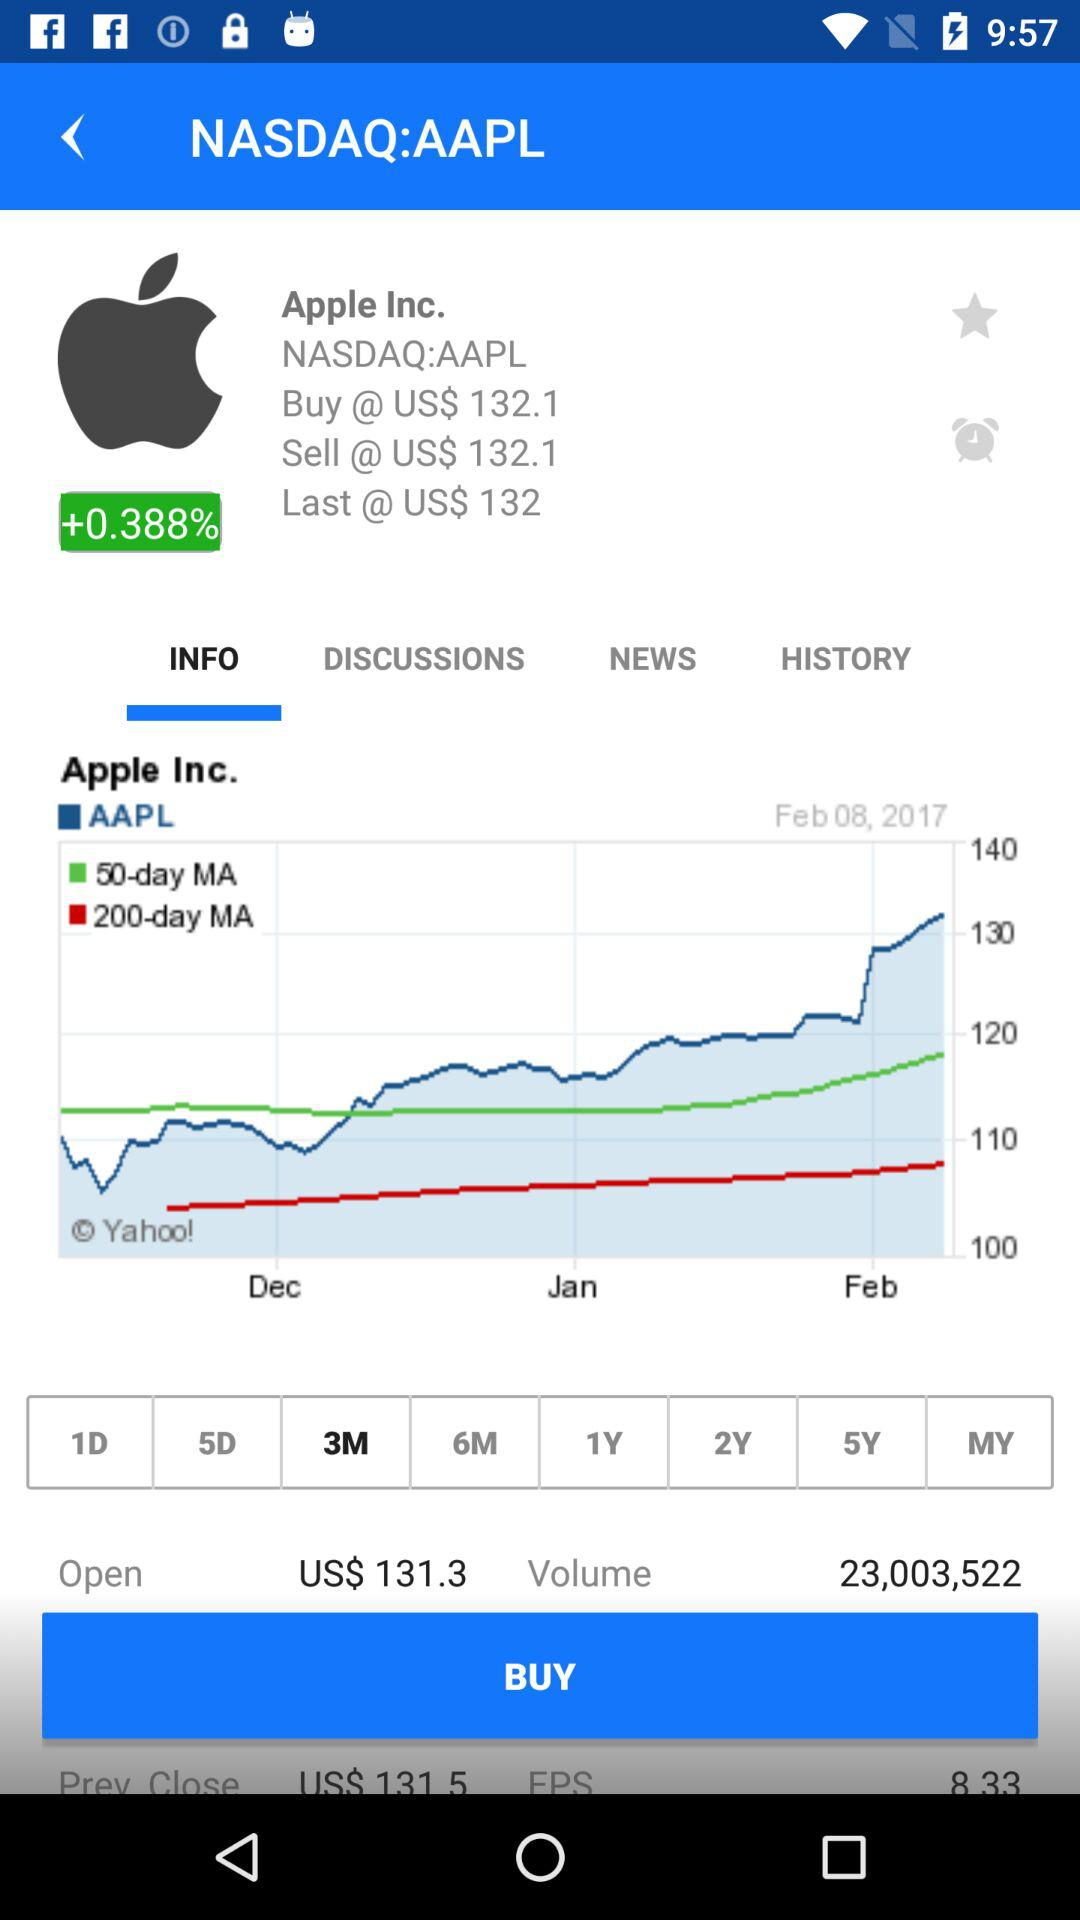What is the volume of this stock?
Answer the question using a single word or phrase. 23,003,522 